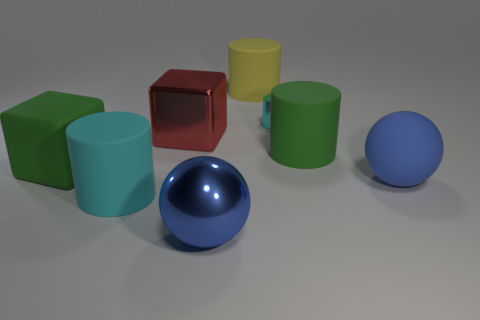Are there any other things that are the same size as the cyan shiny object?
Keep it short and to the point. No. There is a metal object behind the red metallic thing; is it the same color as the matte cylinder that is left of the blue metal object?
Provide a short and direct response. Yes. How many objects are either rubber cylinders in front of the big blue matte object or green objects that are on the left side of the red thing?
Your answer should be very brief. 2. Do the big cylinder that is in front of the green rubber cube and the metallic cylinder have the same color?
Offer a terse response. Yes. What number of other objects are there of the same color as the large metal cube?
Your answer should be compact. 0. What is the material of the big yellow cylinder?
Ensure brevity in your answer.  Rubber. There is a blue sphere in front of the cyan rubber object; does it have the same size as the small metal object?
Ensure brevity in your answer.  No. The shiny thing that is the same shape as the big cyan matte thing is what size?
Offer a very short reply. Small. Are there the same number of big cylinders behind the big green matte cube and large rubber things left of the big blue shiny object?
Make the answer very short. Yes. What is the size of the green object that is left of the big cyan matte cylinder?
Your answer should be very brief. Large. 